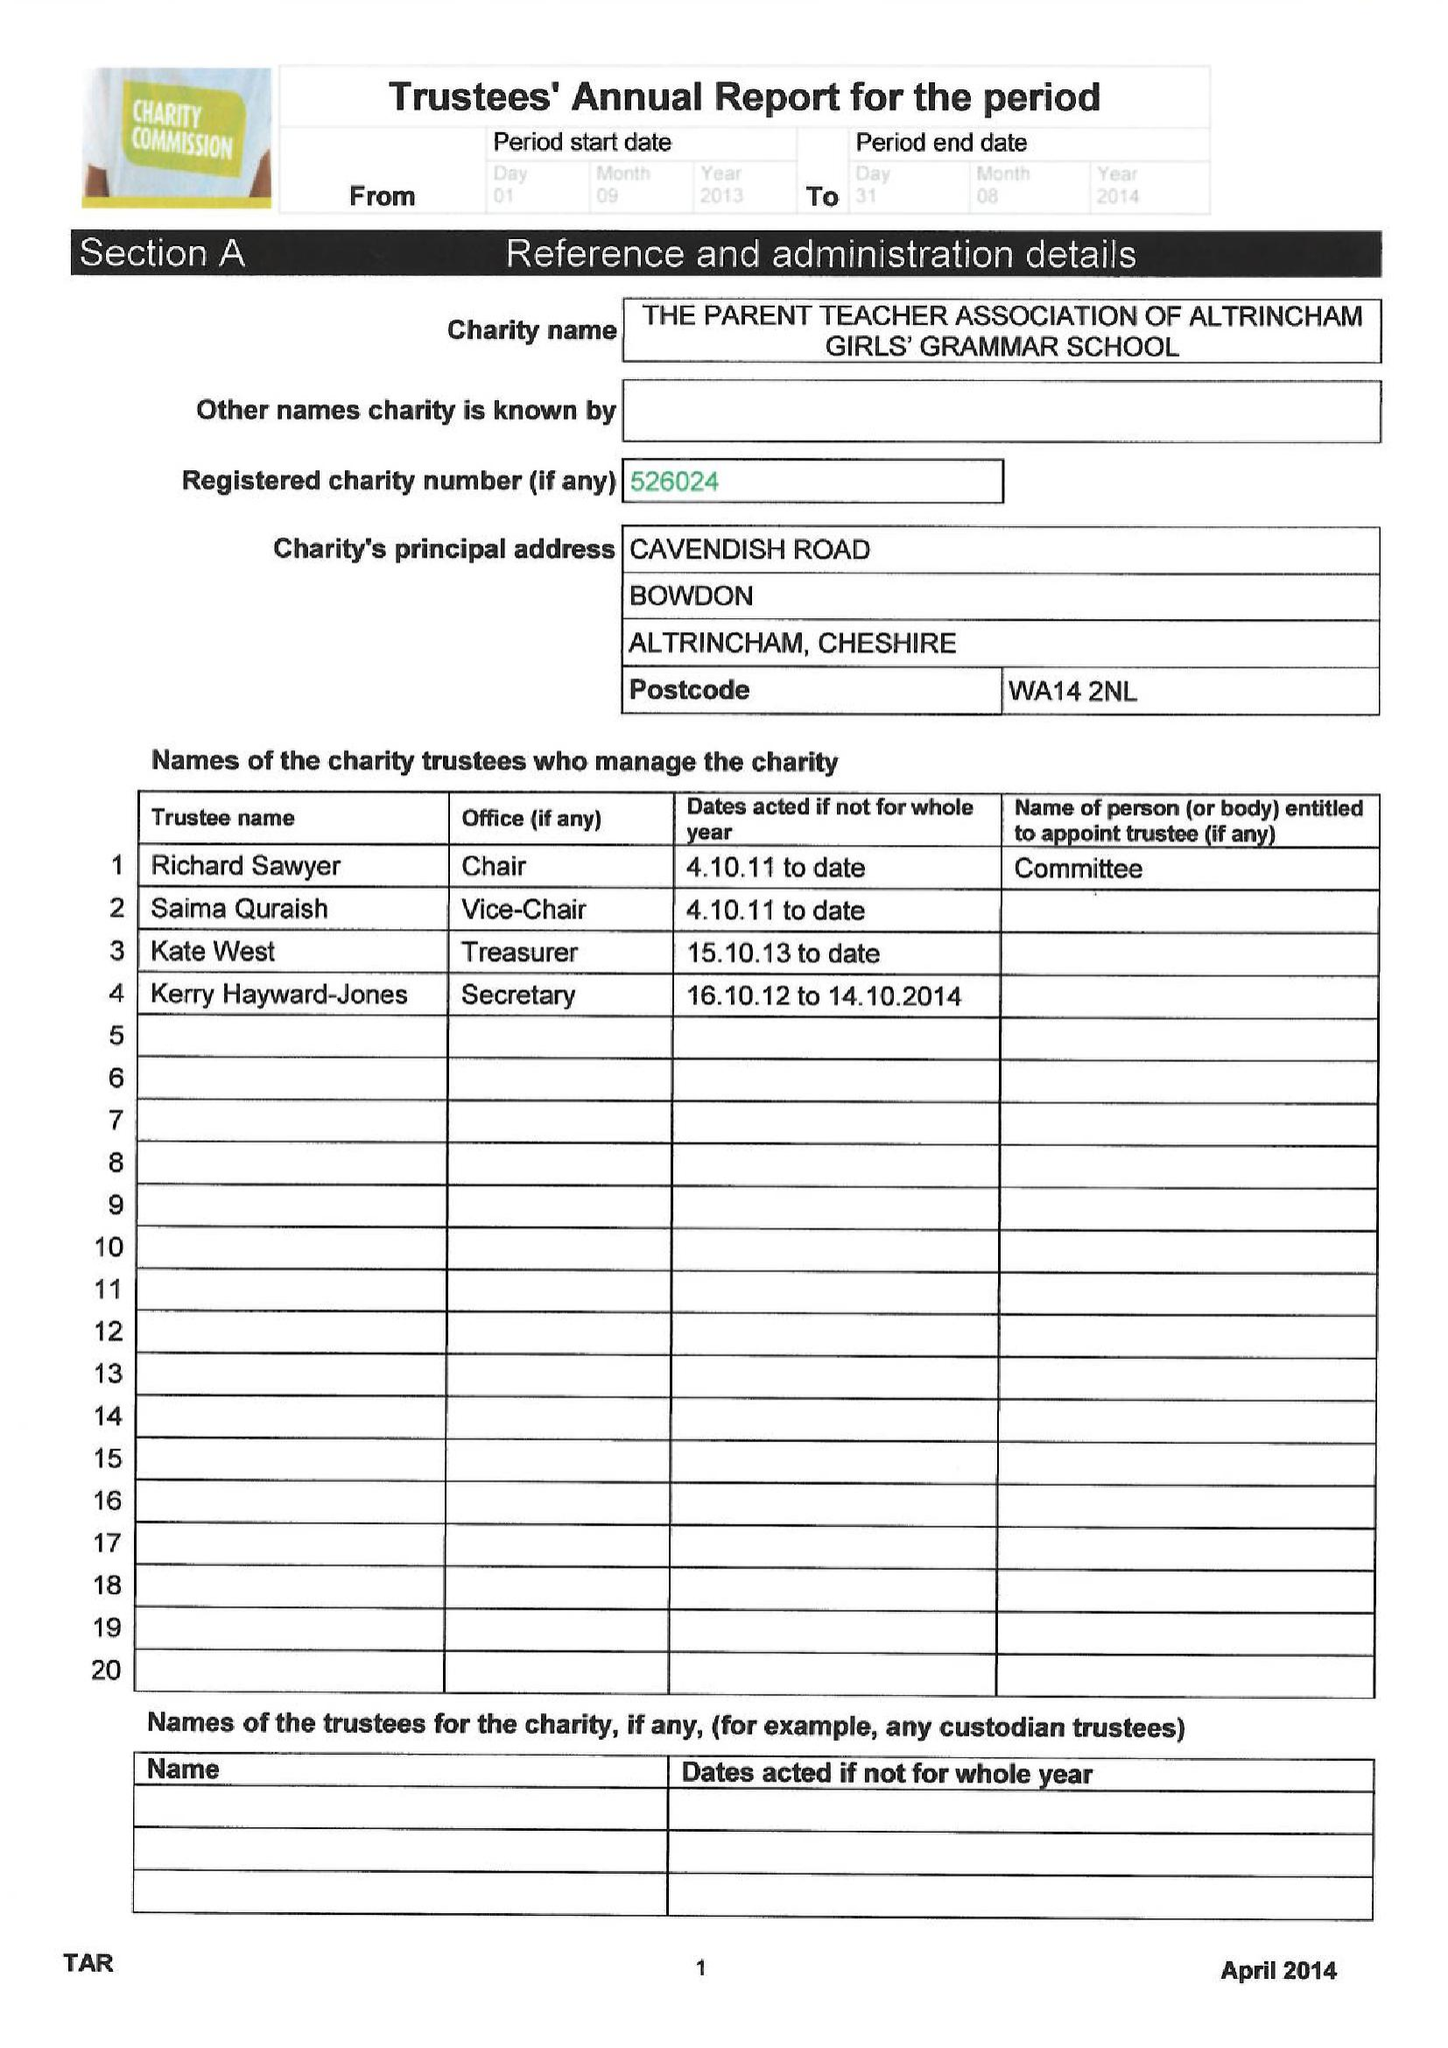What is the value for the income_annually_in_british_pounds?
Answer the question using a single word or phrase. 33625.00 